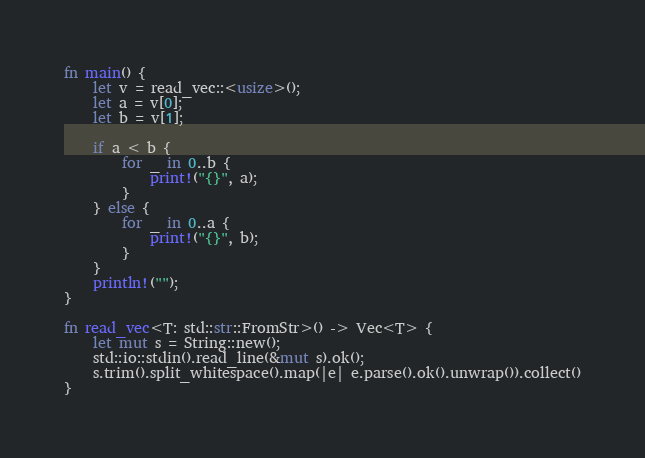Convert code to text. <code><loc_0><loc_0><loc_500><loc_500><_Rust_>fn main() {
    let v = read_vec::<usize>();
    let a = v[0];
    let b = v[1];

    if a < b {
        for _ in 0..b {
            print!("{}", a);
        }
    } else {
        for _ in 0..a {
            print!("{}", b);
        }
    }
    println!("");
}

fn read_vec<T: std::str::FromStr>() -> Vec<T> {
    let mut s = String::new();
    std::io::stdin().read_line(&mut s).ok();
    s.trim().split_whitespace().map(|e| e.parse().ok().unwrap()).collect()
}</code> 